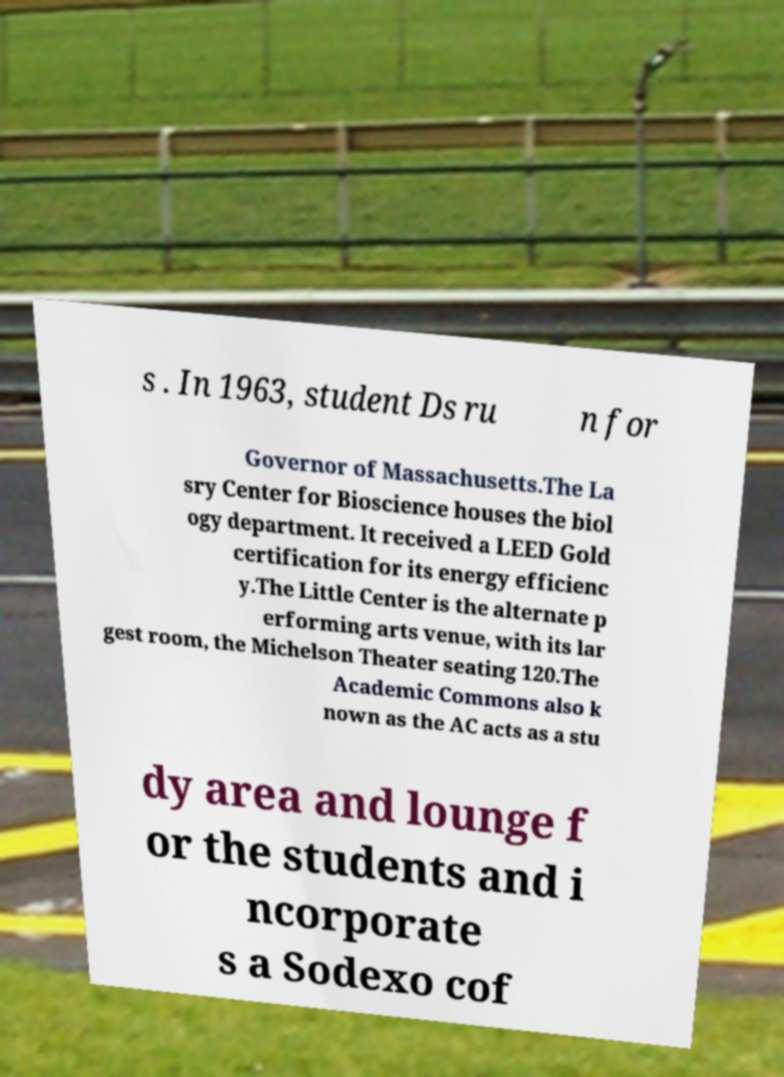There's text embedded in this image that I need extracted. Can you transcribe it verbatim? s . In 1963, student Ds ru n for Governor of Massachusetts.The La sry Center for Bioscience houses the biol ogy department. It received a LEED Gold certification for its energy efficienc y.The Little Center is the alternate p erforming arts venue, with its lar gest room, the Michelson Theater seating 120.The Academic Commons also k nown as the AC acts as a stu dy area and lounge f or the students and i ncorporate s a Sodexo cof 